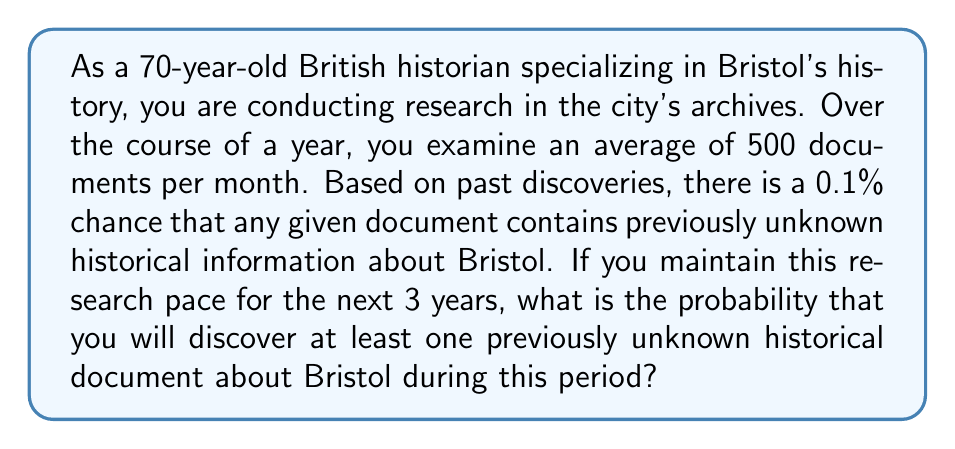Could you help me with this problem? To solve this problem, we'll follow these steps:

1) First, let's calculate the total number of documents examined in 3 years:
   $500 \text{ documents/month} \times 12 \text{ months/year} \times 3 \text{ years} = 18000 \text{ documents}$

2) The probability of a document containing new information is 0.1% or 0.001.

3) We want to find the probability of discovering at least one new document, which is the complement of finding no new documents.

4) The probability of not finding new information in a single document is:
   $1 - 0.001 = 0.999$

5) For all 18000 documents to not contain new information, this must happen 18000 times in a row. We can calculate this using the multiplication rule of probability:
   $P(\text{no new info in 18000 docs}) = (0.999)^{18000}$

6) Therefore, the probability of finding at least one new document is:
   $P(\text{at least one new doc}) = 1 - P(\text{no new info in 18000 docs})$
   $= 1 - (0.999)^{18000}$

7) We can calculate this using a calculator or computer:
   $1 - (0.999)^{18000} \approx 1 - 1.80343775 \times 10^{-8} \approx 0.999999982$

8) Converting to a percentage: $0.999999982 \times 100\% \approx 99.9999982\%$
Answer: The probability of discovering at least one previously unknown historical document about Bristol during the 3-year research period is approximately 99.9999982%. 